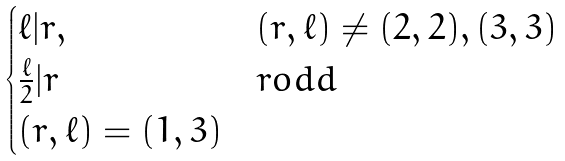<formula> <loc_0><loc_0><loc_500><loc_500>\begin{cases} { \ell } | r , & ( r , { \ell } ) \ne ( 2 , 2 ) , ( 3 , 3 ) \\ \frac { \ell } { 2 } | r & r o d d \\ ( r , { \ell } ) = ( 1 , 3 ) \end{cases}</formula> 